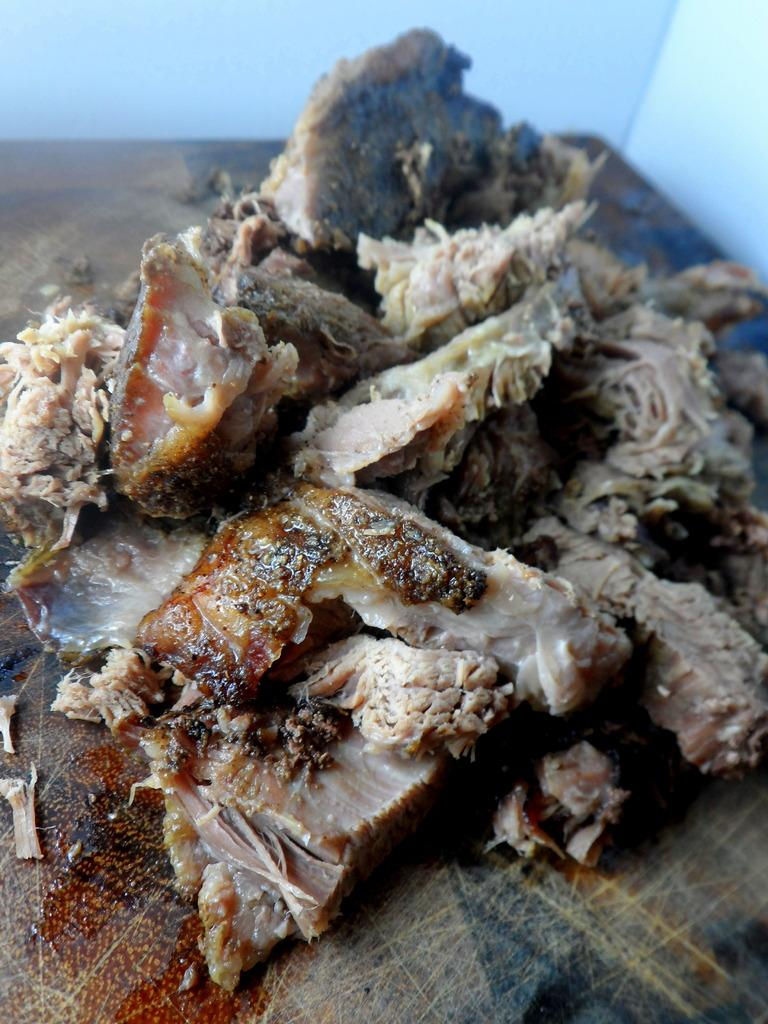What can be seen in the background of the image? There is a wall in the background of the image. What is located at the bottom of the image? There is a wooden board at the bottom of the image. What is on the wooden board in the middle of the image? There is meat on the wooden board in the middle of the image. What type of nut is being stored in the tin on the wooden board? There is no tin or nut present on the wooden board in the image; it only contains meat. What type of produce is visible on the wall in the background? There is no produce visible on the wall in the background of the image. 